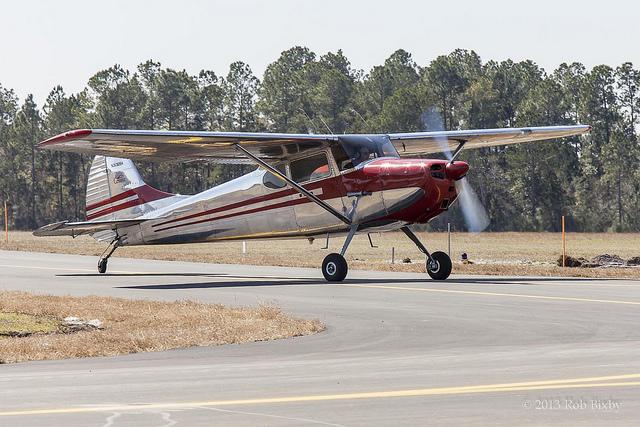How many passengers can ride in this plane at a time?
Keep it brief. 4. What color is the plane?
Give a very brief answer. Red and silver. Is there a co-pilot in the plane?
Concise answer only. No. 